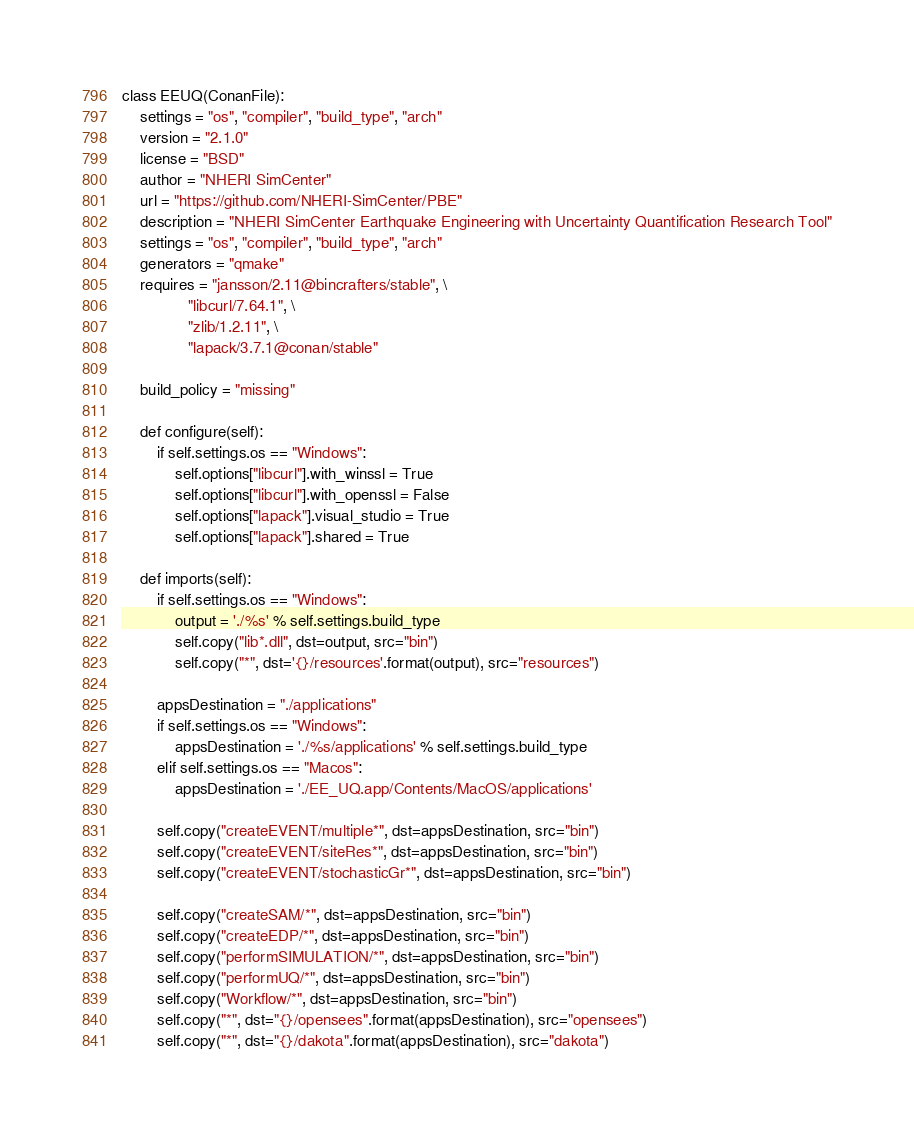Convert code to text. <code><loc_0><loc_0><loc_500><loc_500><_Python_>class EEUQ(ConanFile):
    settings = "os", "compiler", "build_type", "arch"
    version = "2.1.0"
    license = "BSD"
    author = "NHERI SimCenter"
    url = "https://github.com/NHERI-SimCenter/PBE"
    description = "NHERI SimCenter Earthquake Engineering with Uncertainty Quantification Research Tool"
    settings = "os", "compiler", "build_type", "arch"
    generators = "qmake"
    requires = "jansson/2.11@bincrafters/stable", \
               "libcurl/7.64.1", \
               "zlib/1.2.11", \
               "lapack/3.7.1@conan/stable"

    build_policy = "missing"

    def configure(self):
        if self.settings.os == "Windows":
            self.options["libcurl"].with_winssl = True
            self.options["libcurl"].with_openssl = False
            self.options["lapack"].visual_studio = True
            self.options["lapack"].shared = True

    def imports(self):
        if self.settings.os == "Windows":
            output = './%s' % self.settings.build_type
            self.copy("lib*.dll", dst=output, src="bin")
            self.copy("*", dst='{}/resources'.format(output), src="resources")

        appsDestination = "./applications"
        if self.settings.os == "Windows":
            appsDestination = './%s/applications' % self.settings.build_type
        elif self.settings.os == "Macos":
            appsDestination = './EE_UQ.app/Contents/MacOS/applications'

        self.copy("createEVENT/multiple*", dst=appsDestination, src="bin")
        self.copy("createEVENT/siteRes*", dst=appsDestination, src="bin")
        self.copy("createEVENT/stochasticGr*", dst=appsDestination, src="bin")

        self.copy("createSAM/*", dst=appsDestination, src="bin")
        self.copy("createEDP/*", dst=appsDestination, src="bin")
        self.copy("performSIMULATION/*", dst=appsDestination, src="bin")
        self.copy("performUQ/*", dst=appsDestination, src="bin")
        self.copy("Workflow/*", dst=appsDestination, src="bin")
        self.copy("*", dst="{}/opensees".format(appsDestination), src="opensees")
        self.copy("*", dst="{}/dakota".format(appsDestination), src="dakota")
</code> 